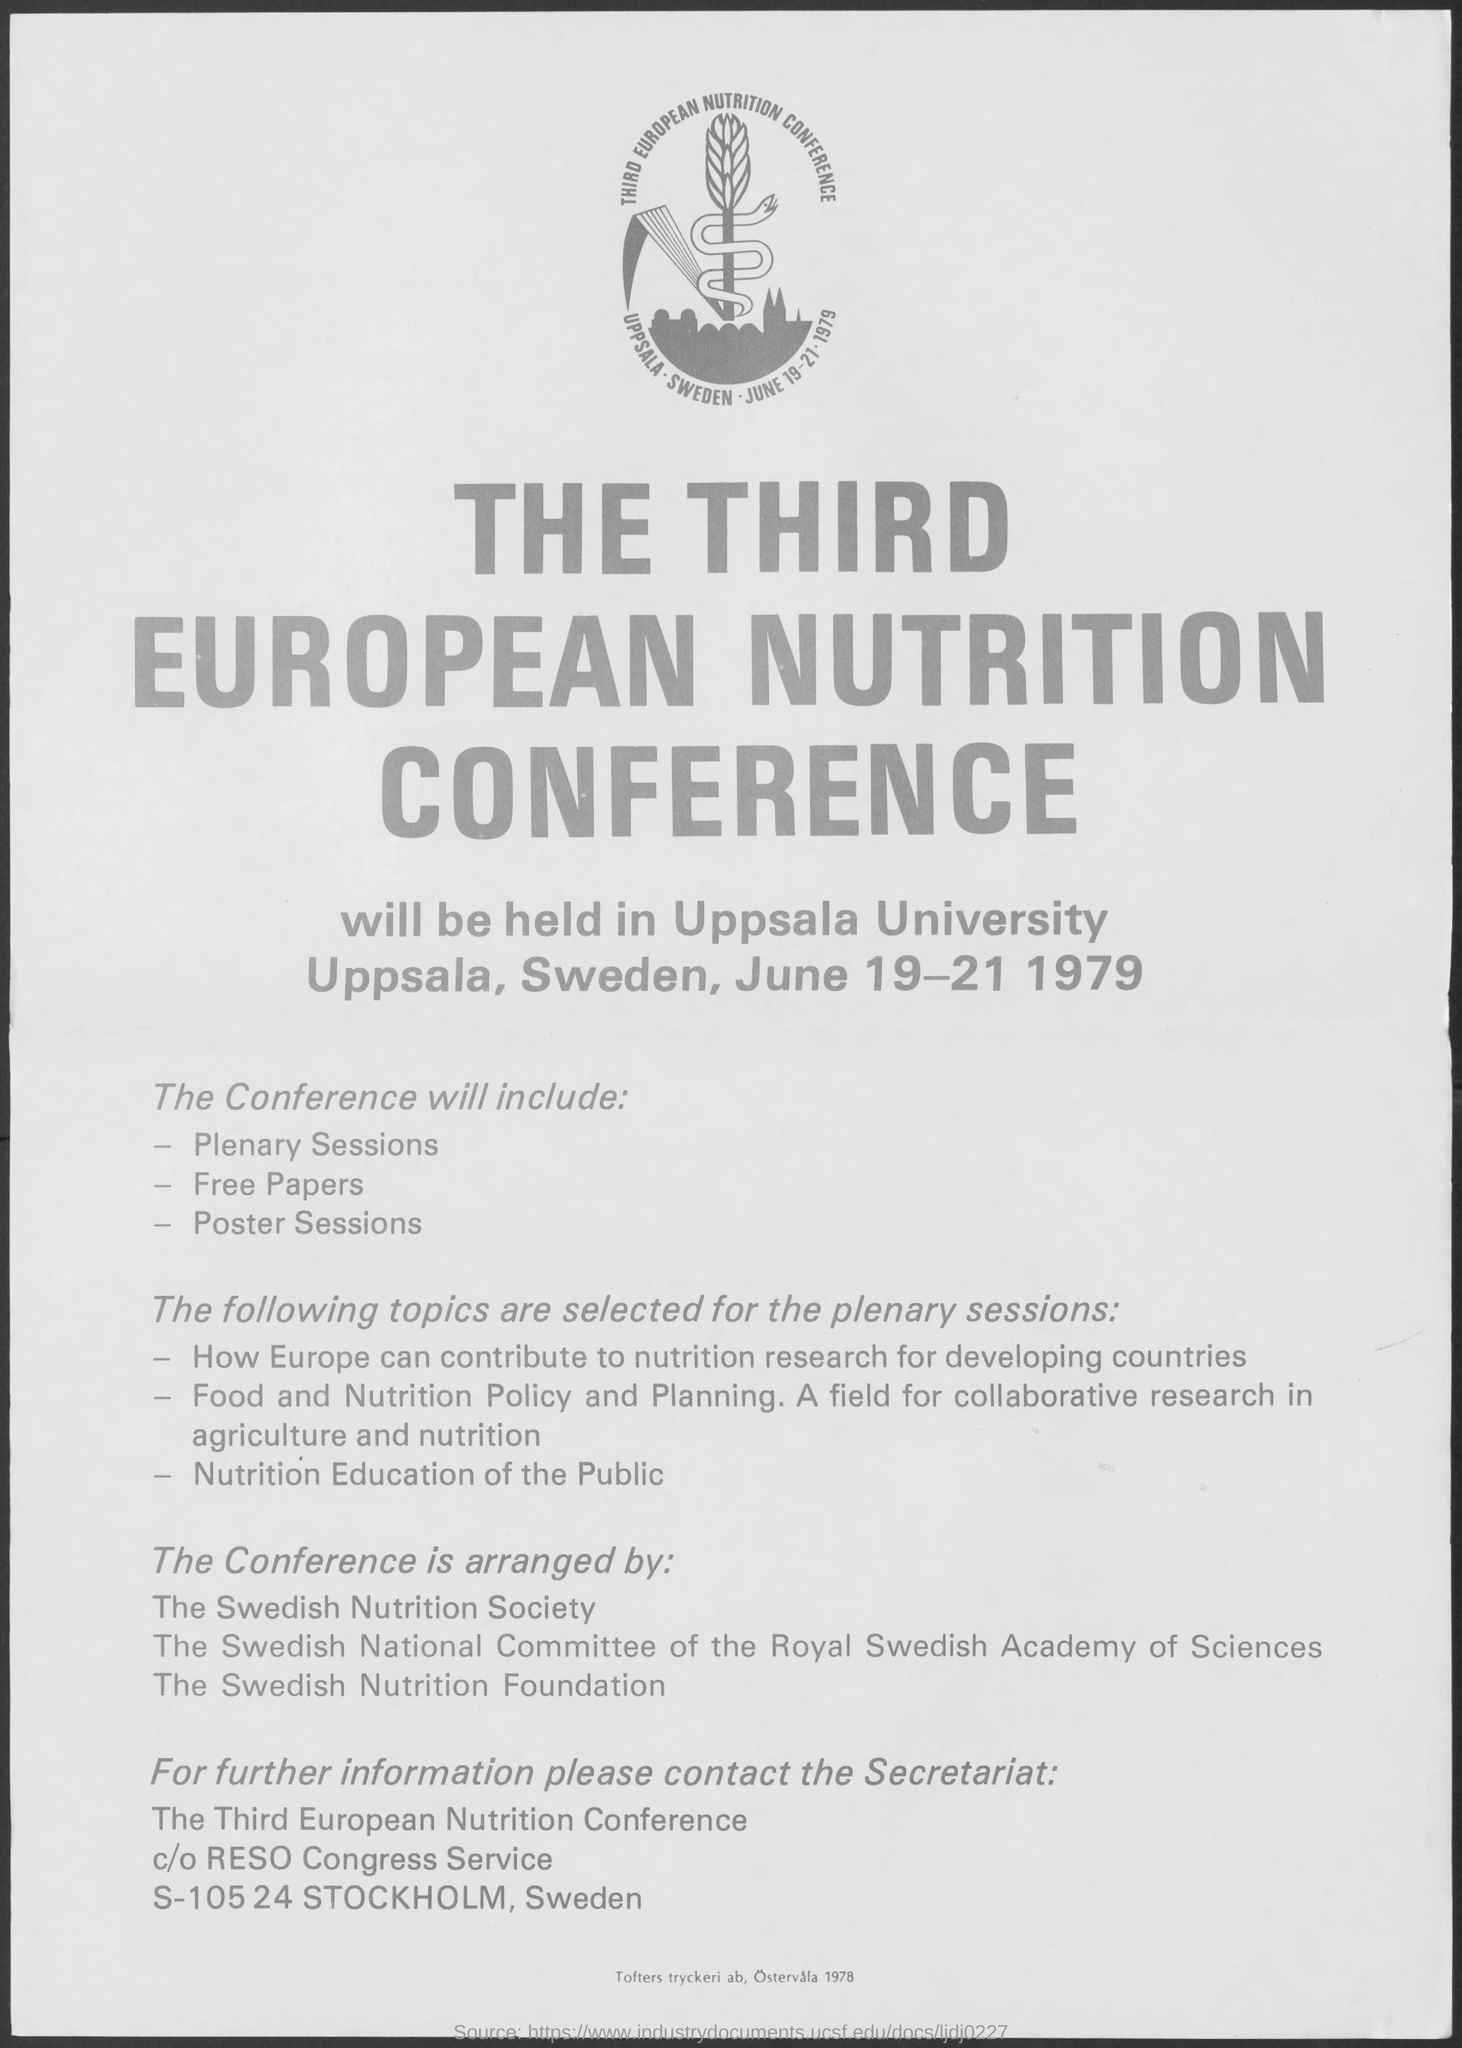List a handful of essential elements in this visual. The Third European Nutrition Conference was held from June 19-21, 1979. 